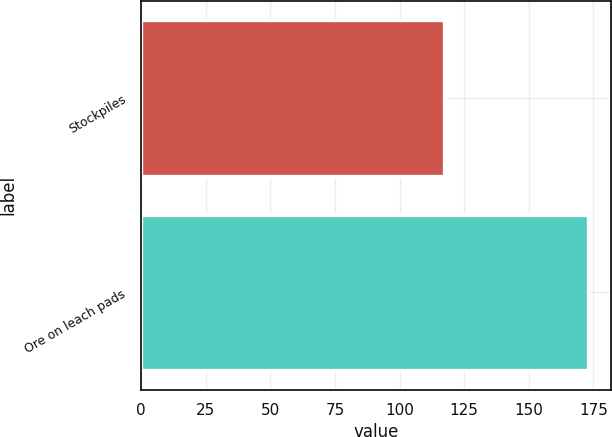<chart> <loc_0><loc_0><loc_500><loc_500><bar_chart><fcel>Stockpiles<fcel>Ore on leach pads<nl><fcel>117<fcel>173<nl></chart> 